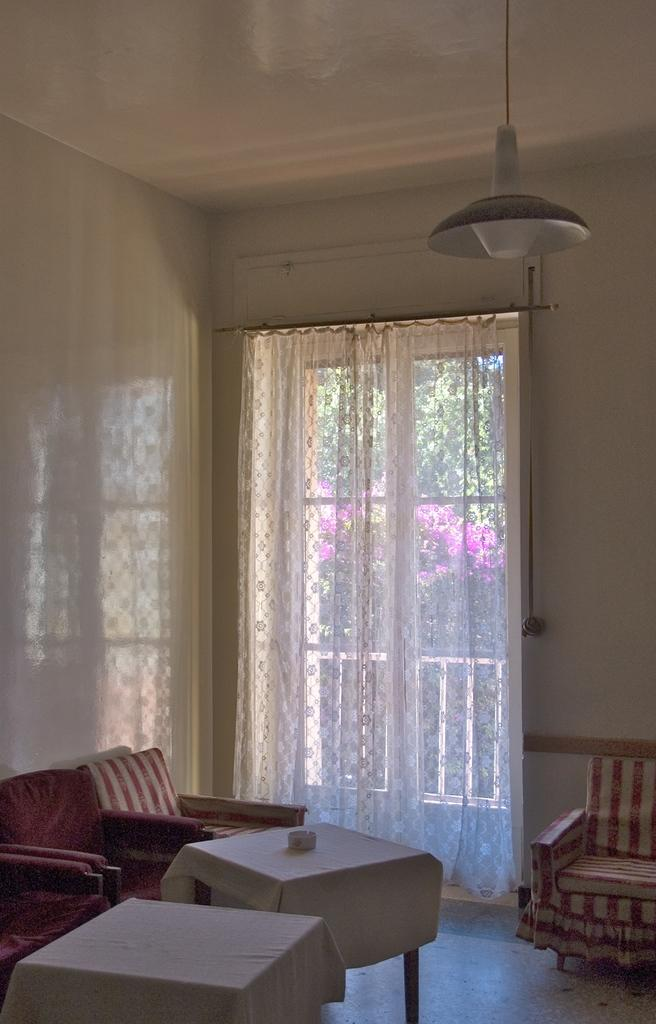What type of furniture is present in the image? There are chairs and tables in the image. What type of window treatment is visible in the image? There is a curtain in the image. What type of illumination is present in the image? There is a light in the image. What type of bells can be heard ringing in the image? There are no bells present in the image, and therefore no sound can be heard. 